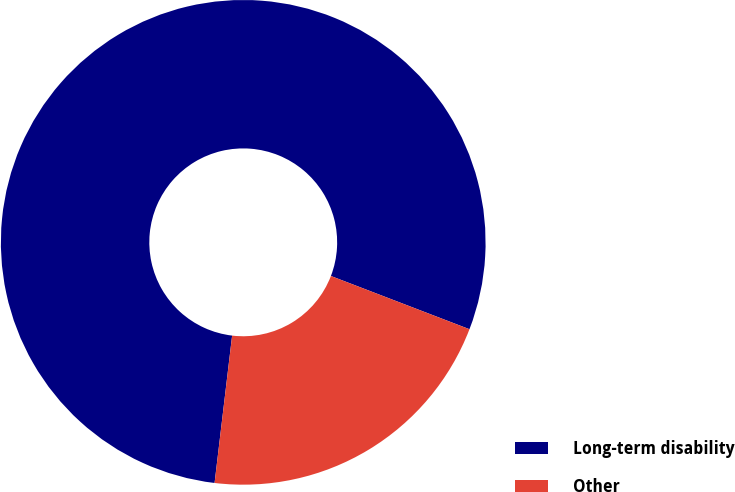Convert chart to OTSL. <chart><loc_0><loc_0><loc_500><loc_500><pie_chart><fcel>Long-term disability<fcel>Other<nl><fcel>78.95%<fcel>21.05%<nl></chart> 